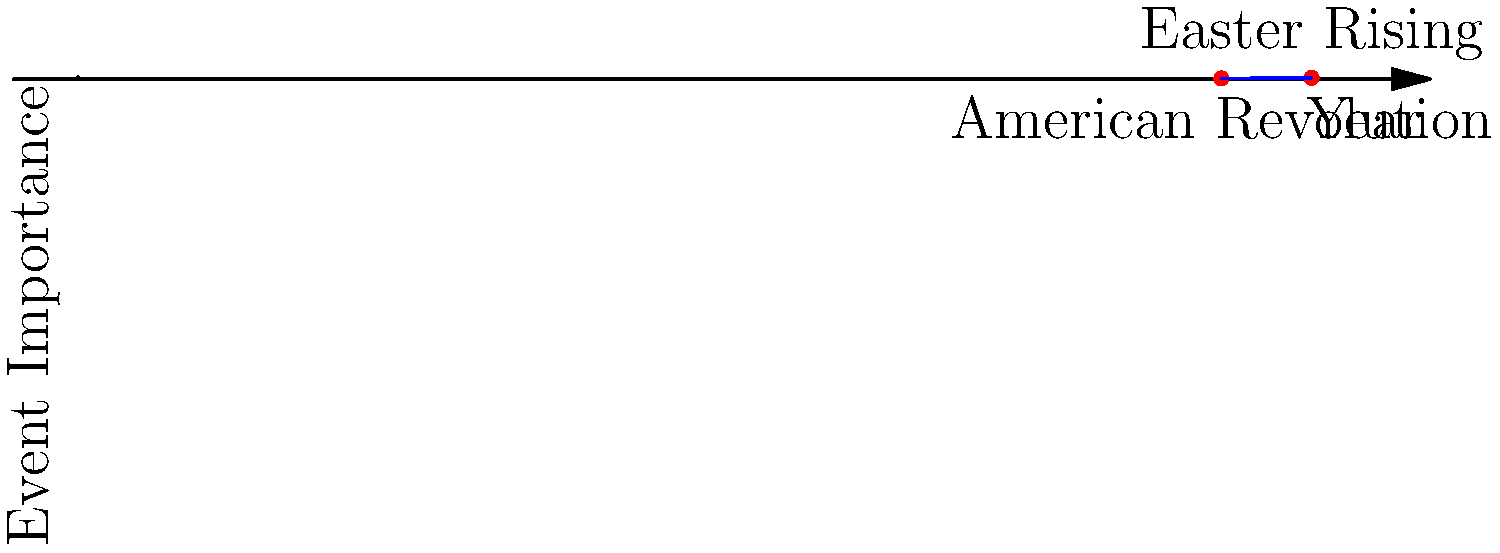On a timeline graph, the American Revolution (1776) and the Easter Rising (1916) are plotted as points $(1776, 1)$ and $(1916, 2)$ respectively, where the x-axis represents years and the y-axis represents the event's historical importance on a scale of 0 to 3. Determine the equation of the line passing through these two significant events in the form $y = mx + b$, where $m$ is the slope and $b$ is the y-intercept. To find the equation of the line, we'll follow these steps:

1) First, calculate the slope $(m)$ using the point-slope formula:
   $m = \frac{y_2 - y_1}{x_2 - x_1} = \frac{2 - 1}{1916 - 1776} = \frac{1}{140} \approx 0.00714$

2) Now that we have the slope, we can use the point-slope form of a line equation:
   $y - y_1 = m(x - x_1)$

3) Let's use the point $(1776, 1)$ and plug in our values:
   $y - 1 = \frac{1}{140}(x - 1776)$

4) Distribute the fraction:
   $y - 1 = \frac{1}{140}x - \frac{1776}{140}$

5) Add 1 to both sides to isolate $y$:
   $y = \frac{1}{140}x - \frac{1776}{140} + 1$

6) Simplify by finding a common denominator:
   $y = \frac{1}{140}x - \frac{1776}{140} + \frac{140}{140} = \frac{1}{140}x - \frac{1636}{140}$

7) This is now in the form $y = mx + b$, where:
   $m = \frac{1}{140}$ and $b = -\frac{1636}{140}$

Therefore, the equation of the line is $y = \frac{1}{140}x - \frac{1636}{140}$.
Answer: $y = \frac{1}{140}x - \frac{1636}{140}$ 